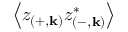<formula> <loc_0><loc_0><loc_500><loc_500>\left \langle z _ { \left ( + , k \right ) } z _ { \left ( - , k \right ) } ^ { * } \right \rangle</formula> 